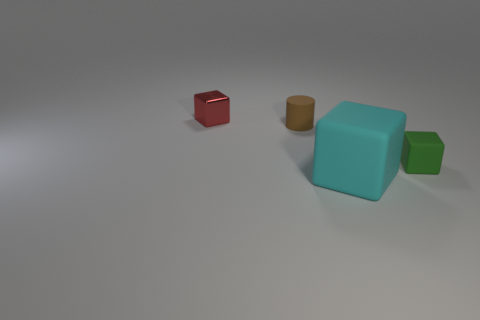What is the color of the other small object that is the same material as the tiny brown object?
Give a very brief answer. Green. Are there more tiny cubes than matte objects?
Offer a terse response. No. How big is the thing that is on the right side of the tiny brown rubber cylinder and behind the cyan block?
Your answer should be compact. Small. Are there the same number of red things that are behind the cyan thing and green shiny cylinders?
Ensure brevity in your answer.  No. Is the size of the red shiny thing the same as the brown rubber thing?
Provide a succinct answer. Yes. There is a matte thing that is on the left side of the green rubber cube and behind the large thing; what is its color?
Offer a terse response. Brown. There is a object that is to the left of the tiny rubber thing behind the green object; what is it made of?
Make the answer very short. Metal. There is a green object that is the same shape as the cyan rubber object; what is its size?
Keep it short and to the point. Small. Does the object that is on the right side of the large cyan block have the same color as the rubber cylinder?
Offer a very short reply. No. Is the number of rubber objects less than the number of brown matte objects?
Your answer should be compact. No. 